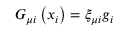Convert formula to latex. <formula><loc_0><loc_0><loc_500><loc_500>G _ { \mu i } \left ( x _ { i } \right ) = \xi _ { \mu i } g _ { i }</formula> 